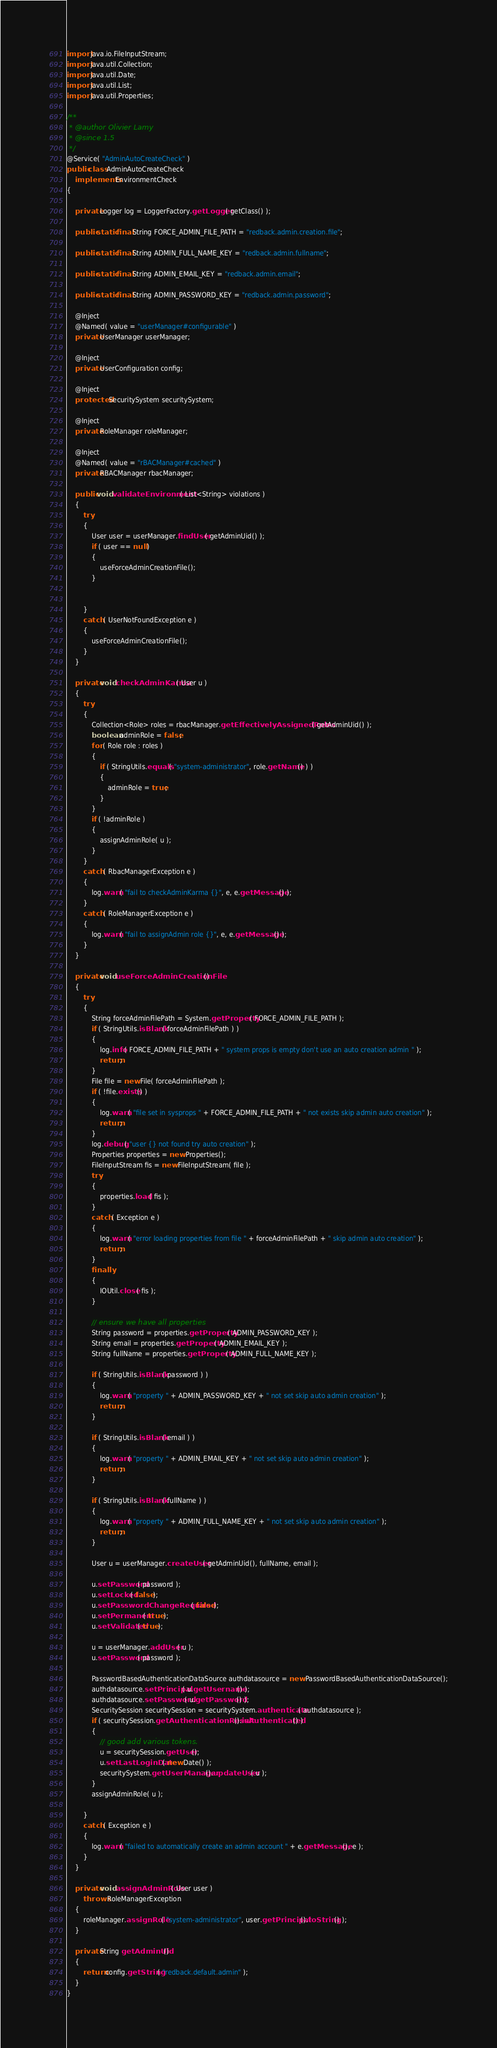Convert code to text. <code><loc_0><loc_0><loc_500><loc_500><_Java_>import java.io.FileInputStream;
import java.util.Collection;
import java.util.Date;
import java.util.List;
import java.util.Properties;

/**
 * @author Olivier Lamy
 * @since 1.5
 */
@Service( "AdminAutoCreateCheck" )
public class AdminAutoCreateCheck
    implements EnvironmentCheck
{

    private Logger log = LoggerFactory.getLogger( getClass() );

    public static final String FORCE_ADMIN_FILE_PATH = "redback.admin.creation.file";

    public static final String ADMIN_FULL_NAME_KEY = "redback.admin.fullname";

    public static final String ADMIN_EMAIL_KEY = "redback.admin.email";

    public static final String ADMIN_PASSWORD_KEY = "redback.admin.password";

    @Inject
    @Named( value = "userManager#configurable" )
    private UserManager userManager;

    @Inject
    private UserConfiguration config;

    @Inject
    protected SecuritySystem securitySystem;

    @Inject
    private RoleManager roleManager;

    @Inject
    @Named( value = "rBACManager#cached" )
    private RBACManager rbacManager;

    public void validateEnvironment( List<String> violations )
    {
        try
        {
            User user = userManager.findUser( getAdminUid() );
            if ( user == null )
            {
                useForceAdminCreationFile();
            }


        }
        catch ( UserNotFoundException e )
        {
            useForceAdminCreationFile();
        }
    }

    private void checkAdminKarma( User u )
    {
        try
        {
            Collection<Role> roles = rbacManager.getEffectivelyAssignedRoles( getAdminUid() );
            boolean adminRole = false;
            for ( Role role : roles )
            {
                if ( StringUtils.equals( "system-administrator", role.getName() ) )
                {
                    adminRole = true;
                }
            }
            if ( !adminRole )
            {
                assignAdminRole( u );
            }
        }
        catch ( RbacManagerException e )
        {
            log.warn( "fail to checkAdminKarma {}", e, e.getMessage() );
        }
        catch ( RoleManagerException e )
        {
            log.warn( "fail to assignAdmin role {}", e, e.getMessage() );
        }
    }

    private void useForceAdminCreationFile()
    {
        try
        {
            String forceAdminFilePath = System.getProperty( FORCE_ADMIN_FILE_PATH );
            if ( StringUtils.isBlank( forceAdminFilePath ) )
            {
                log.info( FORCE_ADMIN_FILE_PATH + " system props is empty don't use an auto creation admin " );
                return;
            }
            File file = new File( forceAdminFilePath );
            if ( !file.exists() )
            {
                log.warn( "file set in sysprops " + FORCE_ADMIN_FILE_PATH + " not exists skip admin auto creation" );
                return;
            }
            log.debug( "user {} not found try auto creation" );
            Properties properties = new Properties();
            FileInputStream fis = new FileInputStream( file );
            try
            {
                properties.load( fis );
            }
            catch ( Exception e )
            {
                log.warn( "error loading properties from file " + forceAdminFilePath + " skip admin auto creation" );
                return;
            }
            finally
            {
                IOUtil.close( fis );
            }

            // ensure we have all properties
            String password = properties.getProperty( ADMIN_PASSWORD_KEY );
            String email = properties.getProperty( ADMIN_EMAIL_KEY );
            String fullName = properties.getProperty( ADMIN_FULL_NAME_KEY );

            if ( StringUtils.isBlank( password ) )
            {
                log.warn( "property " + ADMIN_PASSWORD_KEY + " not set skip auto admin creation" );
                return;
            }

            if ( StringUtils.isBlank( email ) )
            {
                log.warn( "property " + ADMIN_EMAIL_KEY + " not set skip auto admin creation" );
                return;
            }

            if ( StringUtils.isBlank( fullName ) )
            {
                log.warn( "property " + ADMIN_FULL_NAME_KEY + " not set skip auto admin creation" );
                return;
            }

            User u = userManager.createUser( getAdminUid(), fullName, email );

            u.setPassword( password );
            u.setLocked( false );
            u.setPasswordChangeRequired( false );
            u.setPermanent( true );
            u.setValidated( true );

            u = userManager.addUser( u );
            u.setPassword( password );

            PasswordBasedAuthenticationDataSource authdatasource = new PasswordBasedAuthenticationDataSource();
            authdatasource.setPrincipal( u.getUsername() );
            authdatasource.setPassword( u.getPassword() );
            SecuritySession securitySession = securitySystem.authenticate( authdatasource );
            if ( securitySession.getAuthenticationResult().isAuthenticated() )
            {
                // good add various tokens.
                u = securitySession.getUser();
                u.setLastLoginDate( new Date() );
                securitySystem.getUserManager().updateUser( u );
            }
            assignAdminRole( u );

        }
        catch ( Exception e )
        {
            log.warn( "failed to automatically create an admin account " + e.getMessage(), e );
        }
    }

    private void assignAdminRole( User user )
        throws RoleManagerException
    {
        roleManager.assignRole( "system-administrator", user.getPrincipal().toString() );
    }

    private String getAdminUid()
    {
        return config.getString( "redback.default.admin" );
    }
}
</code> 